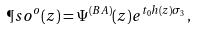<formula> <loc_0><loc_0><loc_500><loc_500>\P s o ^ { o } ( z ) = \Psi ^ { ( B A ) } ( z ) e ^ { t _ { 0 } h ( z ) \sigma _ { 3 } } ,</formula> 